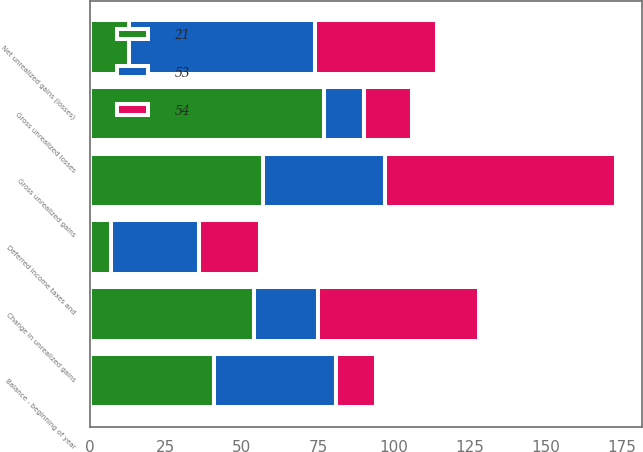Convert chart to OTSL. <chart><loc_0><loc_0><loc_500><loc_500><stacked_bar_chart><ecel><fcel>Gross unrealized gains<fcel>Gross unrealized losses<fcel>Net unrealized gains (losses)<fcel>Deferred income taxes and<fcel>Balance - beginning of year<fcel>Change in unrealized gains<nl><fcel>53<fcel>40<fcel>13<fcel>61<fcel>29<fcel>40<fcel>21<nl><fcel>54<fcel>76<fcel>16<fcel>40<fcel>20<fcel>13<fcel>53<nl><fcel>21<fcel>57<fcel>77<fcel>13<fcel>7<fcel>41<fcel>54<nl></chart> 